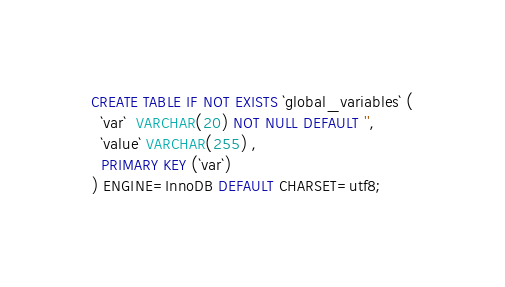Convert code to text. <code><loc_0><loc_0><loc_500><loc_500><_SQL_>CREATE TABLE IF NOT EXISTS `global_variables` (
  `var`  VARCHAR(20) NOT NULL DEFAULT '',
  `value` VARCHAR(255) ,
  PRIMARY KEY (`var`)
) ENGINE=InnoDB DEFAULT CHARSET=utf8;</code> 